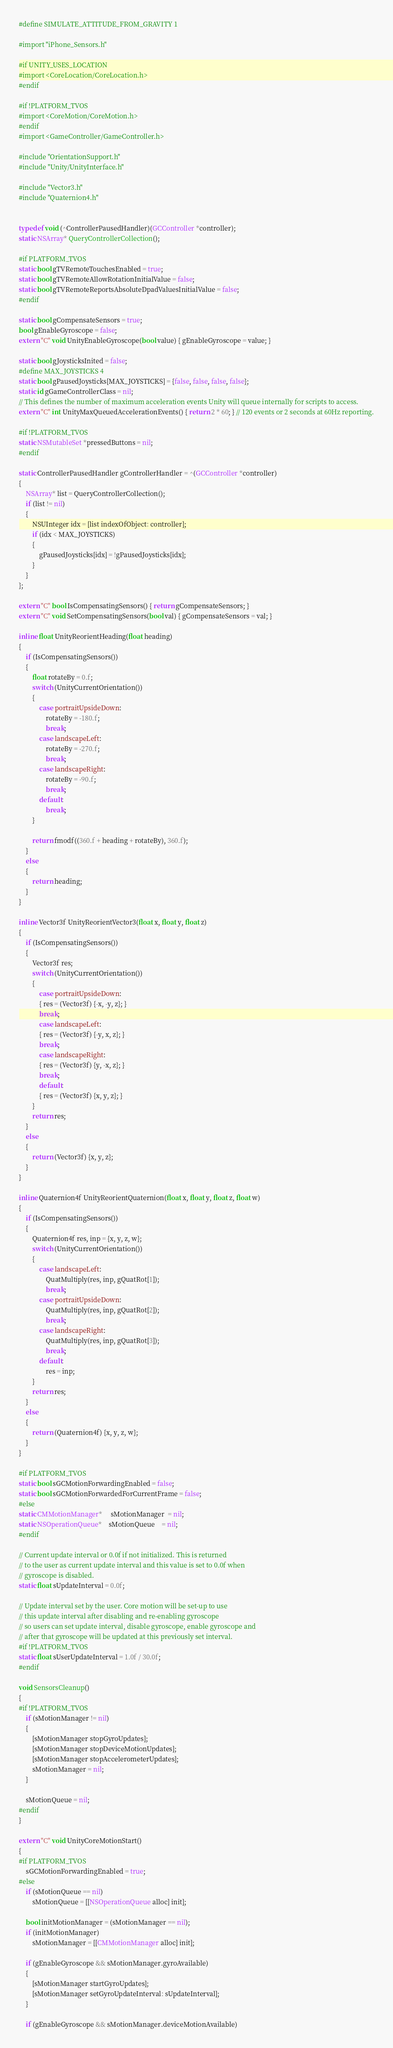Convert code to text. <code><loc_0><loc_0><loc_500><loc_500><_ObjectiveC_>#define SIMULATE_ATTITUDE_FROM_GRAVITY 1

#import "iPhone_Sensors.h"

#if UNITY_USES_LOCATION
#import <CoreLocation/CoreLocation.h>
#endif

#if !PLATFORM_TVOS
#import <CoreMotion/CoreMotion.h>
#endif
#import <GameController/GameController.h>

#include "OrientationSupport.h"
#include "Unity/UnityInterface.h"

#include "Vector3.h"
#include "Quaternion4.h"


typedef void (^ControllerPausedHandler)(GCController *controller);
static NSArray* QueryControllerCollection();

#if PLATFORM_TVOS
static bool gTVRemoteTouchesEnabled = true;
static bool gTVRemoteAllowRotationInitialValue = false;
static bool gTVRemoteReportsAbsoluteDpadValuesInitialValue = false;
#endif

static bool gCompensateSensors = true;
bool gEnableGyroscope = false;
extern "C" void UnityEnableGyroscope(bool value) { gEnableGyroscope = value; }

static bool gJoysticksInited = false;
#define MAX_JOYSTICKS 4
static bool gPausedJoysticks[MAX_JOYSTICKS] = {false, false, false, false};
static id gGameControllerClass = nil;
// This defines the number of maximum acceleration events Unity will queue internally for scripts to access.
extern "C" int UnityMaxQueuedAccelerationEvents() { return 2 * 60; } // 120 events or 2 seconds at 60Hz reporting.

#if !PLATFORM_TVOS
static NSMutableSet *pressedButtons = nil;
#endif

static ControllerPausedHandler gControllerHandler = ^(GCController *controller)
{
    NSArray* list = QueryControllerCollection();
    if (list != nil)
    {
        NSUInteger idx = [list indexOfObject: controller];
        if (idx < MAX_JOYSTICKS)
        {
            gPausedJoysticks[idx] = !gPausedJoysticks[idx];
        }
    }
};

extern "C" bool IsCompensatingSensors() { return gCompensateSensors; }
extern "C" void SetCompensatingSensors(bool val) { gCompensateSensors = val; }

inline float UnityReorientHeading(float heading)
{
    if (IsCompensatingSensors())
    {
        float rotateBy = 0.f;
        switch (UnityCurrentOrientation())
        {
            case portraitUpsideDown:
                rotateBy = -180.f;
                break;
            case landscapeLeft:
                rotateBy = -270.f;
                break;
            case landscapeRight:
                rotateBy = -90.f;
                break;
            default:
                break;
        }

        return fmodf((360.f + heading + rotateBy), 360.f);
    }
    else
    {
        return heading;
    }
}

inline Vector3f UnityReorientVector3(float x, float y, float z)
{
    if (IsCompensatingSensors())
    {
        Vector3f res;
        switch (UnityCurrentOrientation())
        {
            case portraitUpsideDown:
            { res = (Vector3f) {-x, -y, z}; }
            break;
            case landscapeLeft:
            { res = (Vector3f) {-y, x, z}; }
            break;
            case landscapeRight:
            { res = (Vector3f) {y, -x, z}; }
            break;
            default:
            { res = (Vector3f) {x, y, z}; }
        }
        return res;
    }
    else
    {
        return (Vector3f) {x, y, z};
    }
}

inline Quaternion4f UnityReorientQuaternion(float x, float y, float z, float w)
{
    if (IsCompensatingSensors())
    {
        Quaternion4f res, inp = {x, y, z, w};
        switch (UnityCurrentOrientation())
        {
            case landscapeLeft:
                QuatMultiply(res, inp, gQuatRot[1]);
                break;
            case portraitUpsideDown:
                QuatMultiply(res, inp, gQuatRot[2]);
                break;
            case landscapeRight:
                QuatMultiply(res, inp, gQuatRot[3]);
                break;
            default:
                res = inp;
        }
        return res;
    }
    else
    {
        return (Quaternion4f) {x, y, z, w};
    }
}

#if PLATFORM_TVOS
static bool sGCMotionForwardingEnabled = false;
static bool sGCMotionForwardedForCurrentFrame = false;
#else
static CMMotionManager*     sMotionManager  = nil;
static NSOperationQueue*    sMotionQueue    = nil;
#endif

// Current update interval or 0.0f if not initialized. This is returned
// to the user as current update interval and this value is set to 0.0f when
// gyroscope is disabled.
static float sUpdateInterval = 0.0f;

// Update interval set by the user. Core motion will be set-up to use
// this update interval after disabling and re-enabling gyroscope
// so users can set update interval, disable gyroscope, enable gyroscope and
// after that gyroscope will be updated at this previously set interval.
#if !PLATFORM_TVOS
static float sUserUpdateInterval = 1.0f / 30.0f;
#endif

void SensorsCleanup()
{
#if !PLATFORM_TVOS
    if (sMotionManager != nil)
    {
        [sMotionManager stopGyroUpdates];
        [sMotionManager stopDeviceMotionUpdates];
        [sMotionManager stopAccelerometerUpdates];
        sMotionManager = nil;
    }

    sMotionQueue = nil;
#endif
}

extern "C" void UnityCoreMotionStart()
{
#if PLATFORM_TVOS
    sGCMotionForwardingEnabled = true;
#else
    if (sMotionQueue == nil)
        sMotionQueue = [[NSOperationQueue alloc] init];

    bool initMotionManager = (sMotionManager == nil);
    if (initMotionManager)
        sMotionManager = [[CMMotionManager alloc] init];

    if (gEnableGyroscope && sMotionManager.gyroAvailable)
    {
        [sMotionManager startGyroUpdates];
        [sMotionManager setGyroUpdateInterval: sUpdateInterval];
    }

    if (gEnableGyroscope && sMotionManager.deviceMotionAvailable)</code> 